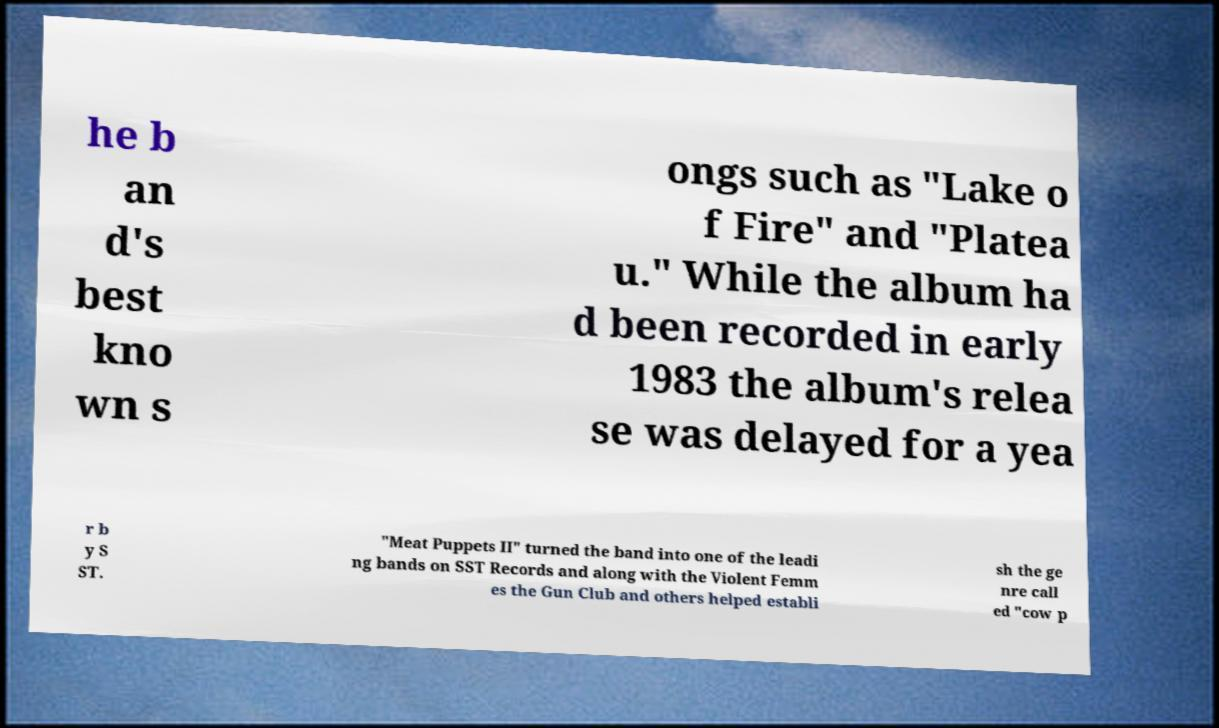There's text embedded in this image that I need extracted. Can you transcribe it verbatim? he b an d's best kno wn s ongs such as "Lake o f Fire" and "Platea u." While the album ha d been recorded in early 1983 the album's relea se was delayed for a yea r b y S ST. "Meat Puppets II" turned the band into one of the leadi ng bands on SST Records and along with the Violent Femm es the Gun Club and others helped establi sh the ge nre call ed "cow p 